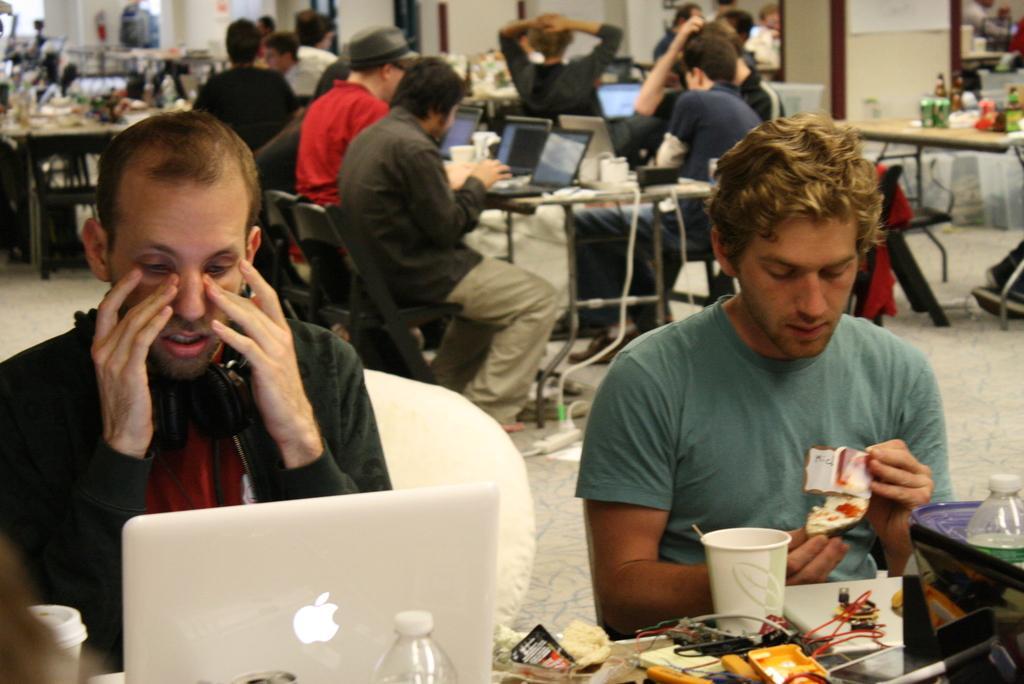Describe this image in one or two sentences. As we can see in the image there is a wall, few people sitting on chairs and there is a table. On table there is a bottle, glass and laptop 